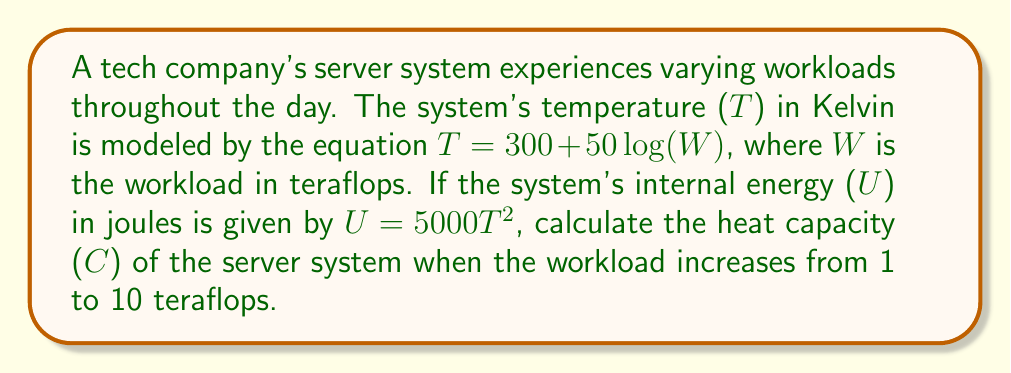What is the answer to this math problem? To solve this problem, we'll follow these steps:

1) The heat capacity C is defined as $C = \frac{dU}{dT}$.

2) We need to express U in terms of W:
   $U = 5000T^2 = 5000(300 + 50\log(W))^2$

3) Now we need to find $\frac{dU}{dW}$:
   $$\frac{dU}{dW} = 5000 \cdot 2(300 + 50\log(W)) \cdot \frac{50}{W\ln(10)}$$

4) We also need $\frac{dT}{dW}$:
   $$\frac{dT}{dW} = \frac{50}{W\ln(10)}$$

5) Using the chain rule:
   $$C = \frac{dU}{dT} = \frac{dU}{dW} \cdot \frac{dW}{dT} = \frac{dU}{dW} \cdot \frac{1}{\frac{dT}{dW}}$$

6) Substituting the expressions we found:
   $$C = \frac{5000 \cdot 2(300 + 50\log(W)) \cdot \frac{50}{W\ln(10)}}{\frac{50}{W\ln(10)}}$$

7) Simplifying:
   $$C = 10000(300 + 50\log(W))$$

8) To find the change in heat capacity, we calculate C at W=10 and W=1:
   $C_{10} = 10000(300 + 50\log(10)) = 4151150.27$ J/K
   $C_1 = 10000(300 + 50\log(1)) = 3000000$ J/K

9) The change in heat capacity is:
   $\Delta C = C_{10} - C_1 = 1151150.27$ J/K
Answer: 1151150.27 J/K 